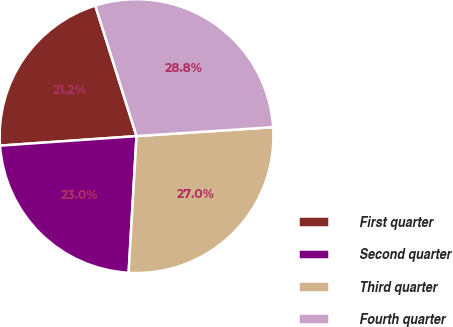Convert chart. <chart><loc_0><loc_0><loc_500><loc_500><pie_chart><fcel>First quarter<fcel>Second quarter<fcel>Third quarter<fcel>Fourth quarter<nl><fcel>21.24%<fcel>22.97%<fcel>26.96%<fcel>28.83%<nl></chart> 